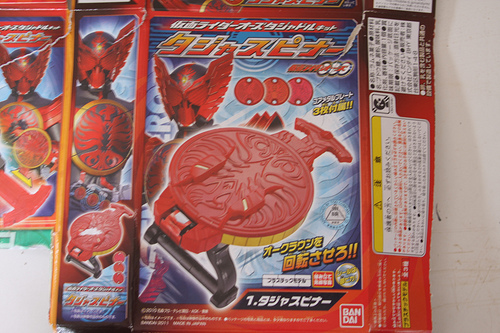<image>
Is there a label next to the mask? No. The label is not positioned next to the mask. They are located in different areas of the scene. 